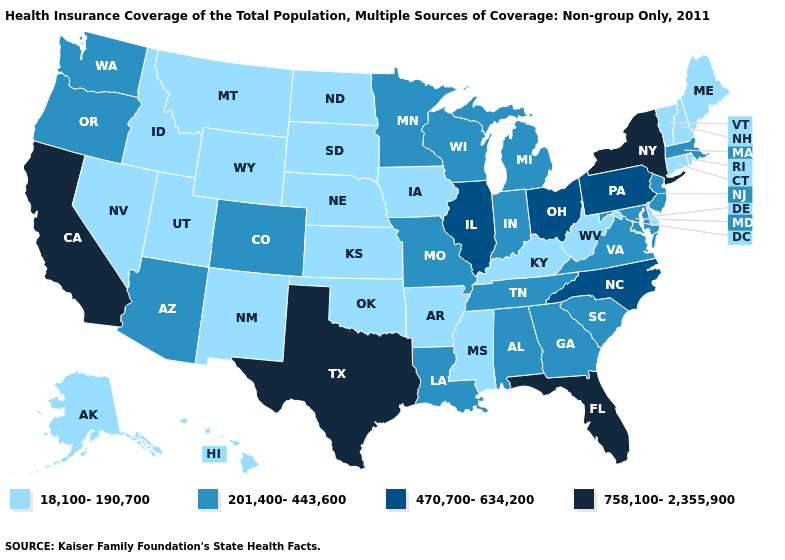Name the states that have a value in the range 18,100-190,700?
Quick response, please. Alaska, Arkansas, Connecticut, Delaware, Hawaii, Idaho, Iowa, Kansas, Kentucky, Maine, Mississippi, Montana, Nebraska, Nevada, New Hampshire, New Mexico, North Dakota, Oklahoma, Rhode Island, South Dakota, Utah, Vermont, West Virginia, Wyoming. Which states hav the highest value in the South?
Quick response, please. Florida, Texas. What is the value of Tennessee?
Keep it brief. 201,400-443,600. Name the states that have a value in the range 18,100-190,700?
Short answer required. Alaska, Arkansas, Connecticut, Delaware, Hawaii, Idaho, Iowa, Kansas, Kentucky, Maine, Mississippi, Montana, Nebraska, Nevada, New Hampshire, New Mexico, North Dakota, Oklahoma, Rhode Island, South Dakota, Utah, Vermont, West Virginia, Wyoming. Which states have the lowest value in the South?
Short answer required. Arkansas, Delaware, Kentucky, Mississippi, Oklahoma, West Virginia. What is the value of Delaware?
Give a very brief answer. 18,100-190,700. Does Ohio have a lower value than California?
Concise answer only. Yes. Name the states that have a value in the range 18,100-190,700?
Quick response, please. Alaska, Arkansas, Connecticut, Delaware, Hawaii, Idaho, Iowa, Kansas, Kentucky, Maine, Mississippi, Montana, Nebraska, Nevada, New Hampshire, New Mexico, North Dakota, Oklahoma, Rhode Island, South Dakota, Utah, Vermont, West Virginia, Wyoming. Which states hav the highest value in the Northeast?
Short answer required. New York. Name the states that have a value in the range 18,100-190,700?
Quick response, please. Alaska, Arkansas, Connecticut, Delaware, Hawaii, Idaho, Iowa, Kansas, Kentucky, Maine, Mississippi, Montana, Nebraska, Nevada, New Hampshire, New Mexico, North Dakota, Oklahoma, Rhode Island, South Dakota, Utah, Vermont, West Virginia, Wyoming. Among the states that border Louisiana , does Arkansas have the lowest value?
Keep it brief. Yes. Which states hav the highest value in the West?
Write a very short answer. California. Which states have the highest value in the USA?
Short answer required. California, Florida, New York, Texas. Does the map have missing data?
Give a very brief answer. No. 